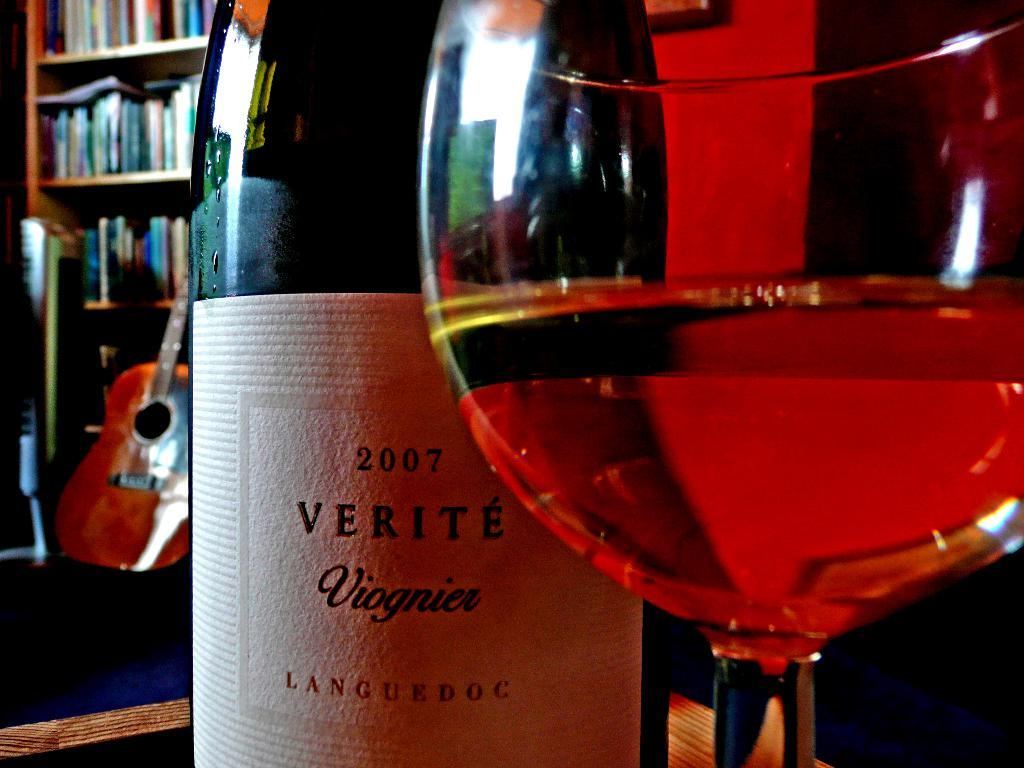What object is on the table in the image? There is a green bottle and a glass of drink on the table. What can be seen in the background of the image? There is a bookshelf and a guitar in the background. What type of flesh can be seen on the guitar in the image? There is no flesh visible on the guitar in the image; it is a musical instrument made of wood and other materials. 